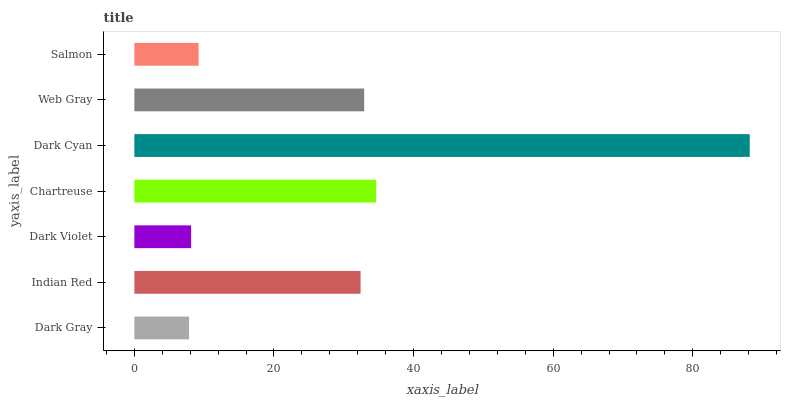Is Dark Gray the minimum?
Answer yes or no. Yes. Is Dark Cyan the maximum?
Answer yes or no. Yes. Is Indian Red the minimum?
Answer yes or no. No. Is Indian Red the maximum?
Answer yes or no. No. Is Indian Red greater than Dark Gray?
Answer yes or no. Yes. Is Dark Gray less than Indian Red?
Answer yes or no. Yes. Is Dark Gray greater than Indian Red?
Answer yes or no. No. Is Indian Red less than Dark Gray?
Answer yes or no. No. Is Indian Red the high median?
Answer yes or no. Yes. Is Indian Red the low median?
Answer yes or no. Yes. Is Chartreuse the high median?
Answer yes or no. No. Is Web Gray the low median?
Answer yes or no. No. 